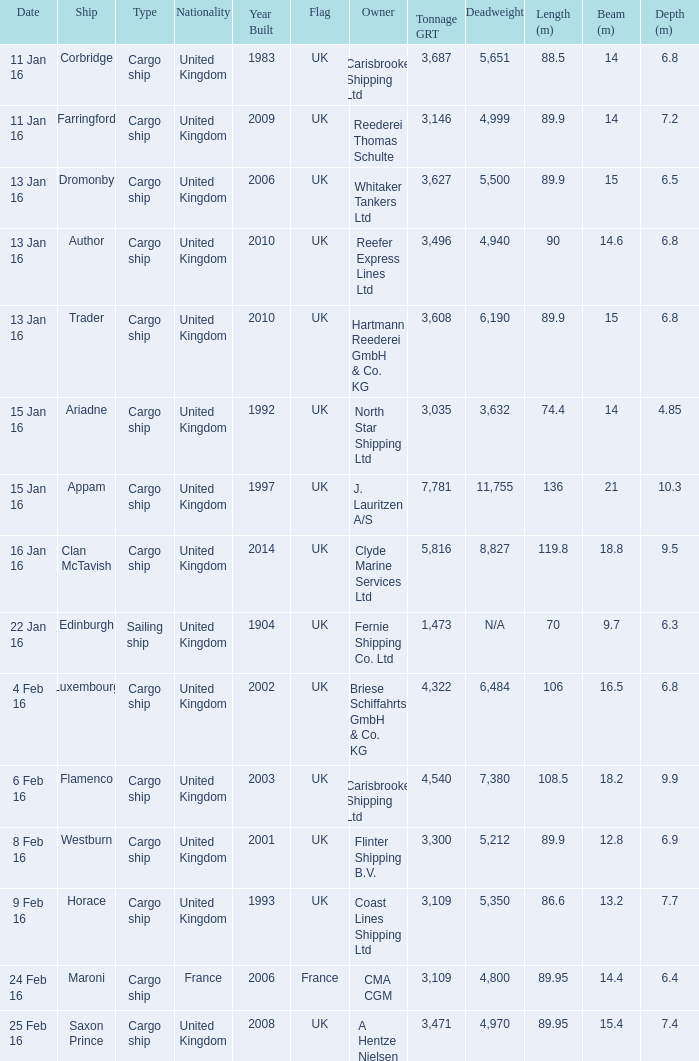What is the most tonnage grt of any ship sunk or captured on 16 jan 16? 5816.0. 